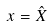<formula> <loc_0><loc_0><loc_500><loc_500>x = \hat { X }</formula> 